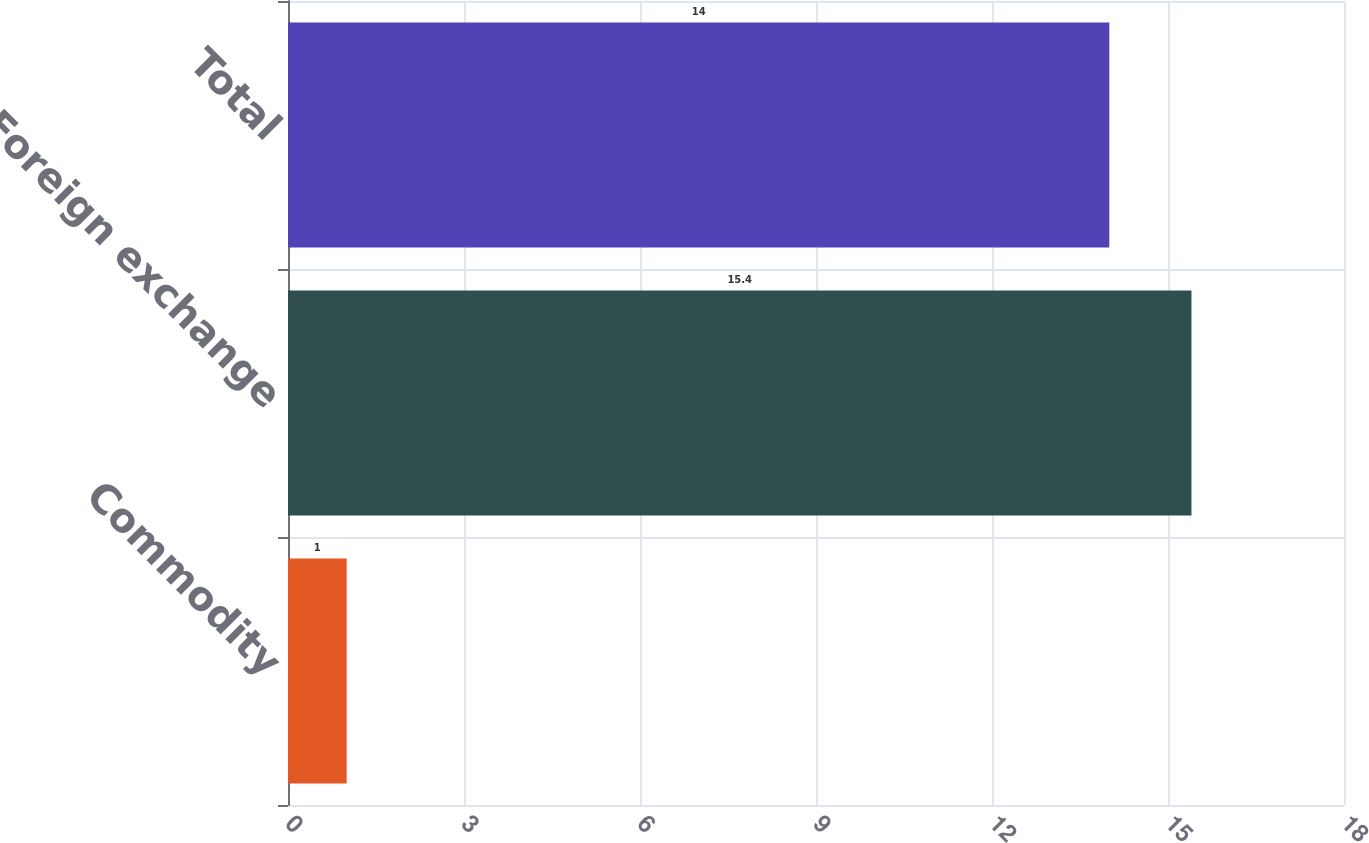<chart> <loc_0><loc_0><loc_500><loc_500><bar_chart><fcel>Commodity<fcel>Foreign exchange<fcel>Total<nl><fcel>1<fcel>15.4<fcel>14<nl></chart> 